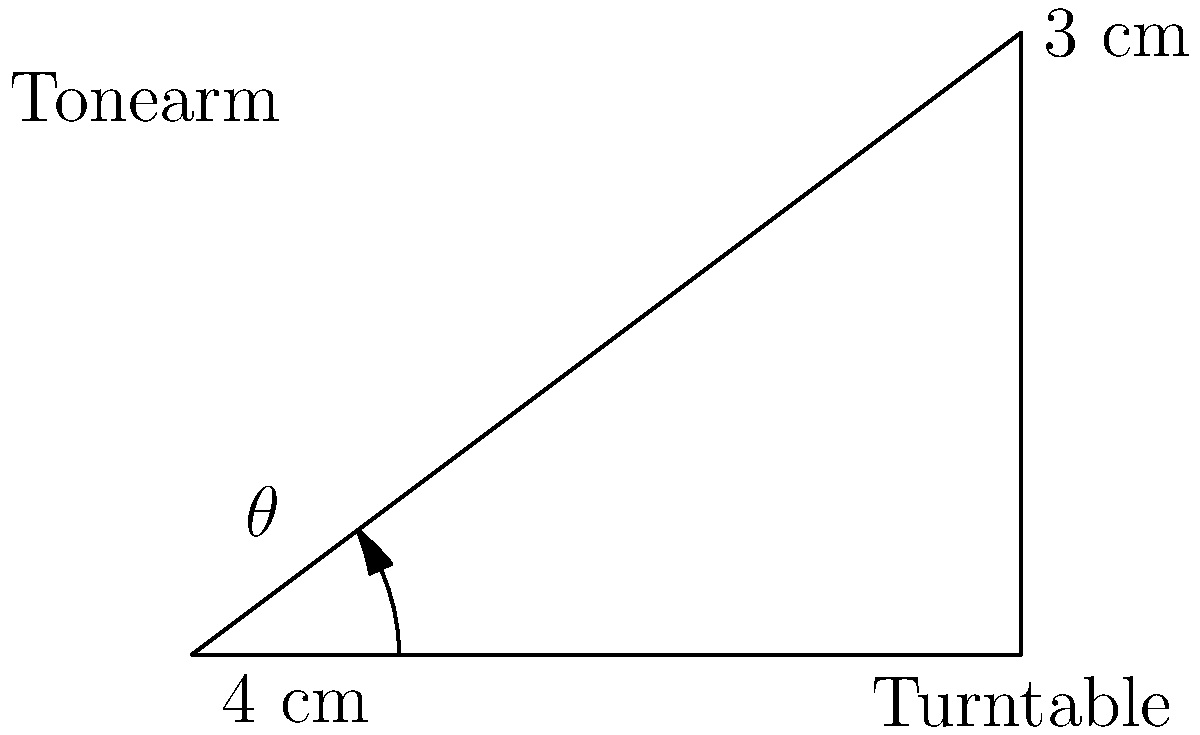You're setting up your vintage Technics SL-1200 turntable for optimal sound quality. The tonearm is 4 cm long, and the cartridge needs to be positioned 3 cm above the turntable surface for the best performance. What is the optimal angle $\theta$ (in degrees) at which the tonearm should be set? Let's approach this step-by-step:

1) We can treat this as a right-angled triangle problem, where:
   - The hypotenuse is the tonearm (4 cm)
   - The opposite side is the height above the turntable (3 cm)
   - The adjacent side is the horizontal distance from the tonearm pivot to the cartridge

2) We need to find the angle $\theta$ between the tonearm and the turntable surface.

3) In a right-angled triangle, we can use the trigonometric function sine:

   $$\sin \theta = \frac{\text{opposite}}{\text{hypotenuse}} = \frac{3}{4}$$

4) To find $\theta$, we need to use the inverse sine function (arcsin or $\sin^{-1}$):

   $$\theta = \sin^{-1}\left(\frac{3}{4}\right)$$

5) Using a calculator or computer:

   $$\theta \approx 48.59^\circ$$

6) Round to two decimal places for practical application.

Therefore, the optimal angle for the tonearm is approximately 48.59°.
Answer: $48.59^\circ$ 